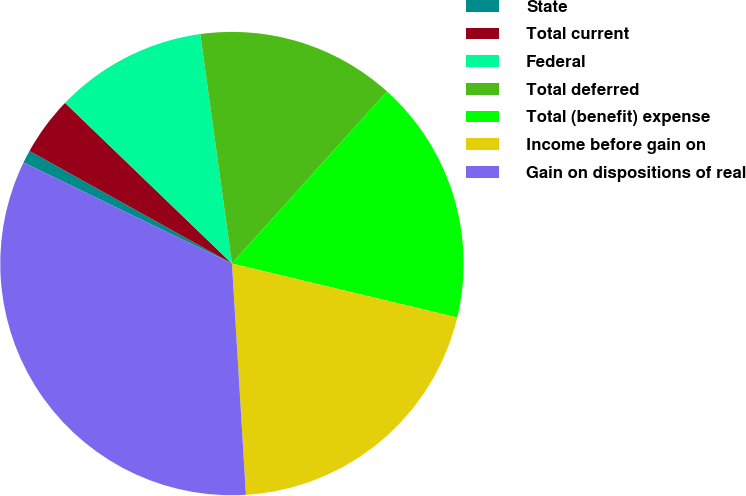Convert chart to OTSL. <chart><loc_0><loc_0><loc_500><loc_500><pie_chart><fcel>State<fcel>Total current<fcel>Federal<fcel>Total deferred<fcel>Total (benefit) expense<fcel>Income before gain on<fcel>Gain on dispositions of real<nl><fcel>0.89%<fcel>4.12%<fcel>10.62%<fcel>13.85%<fcel>17.07%<fcel>20.3%<fcel>33.15%<nl></chart> 